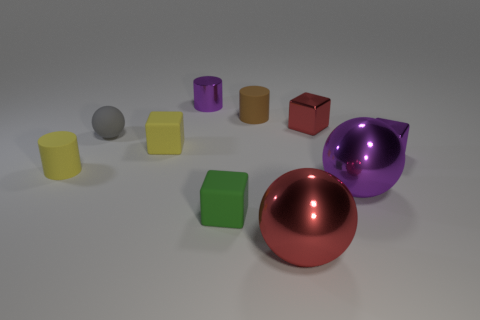What number of balls are either small brown matte objects or tiny purple things?
Your answer should be compact. 0. What is the color of the metallic thing that is the same size as the red metallic ball?
Offer a terse response. Purple. How many cubes are both left of the large red ball and behind the tiny purple metal block?
Provide a short and direct response. 1. What material is the yellow cylinder?
Keep it short and to the point. Rubber. What number of objects are tiny red shiny things or tiny brown matte things?
Offer a very short reply. 2. Do the metallic ball that is on the right side of the red sphere and the gray object that is left of the small yellow cube have the same size?
Your answer should be very brief. No. How many other objects are there of the same size as the purple metal sphere?
Make the answer very short. 1. How many objects are matte blocks that are in front of the purple shiny sphere or small metallic cubes that are behind the purple metal cube?
Give a very brief answer. 2. Does the brown object have the same material as the tiny purple thing to the left of the tiny purple shiny block?
Give a very brief answer. No. What number of other things are there of the same shape as the small gray thing?
Offer a terse response. 2. 